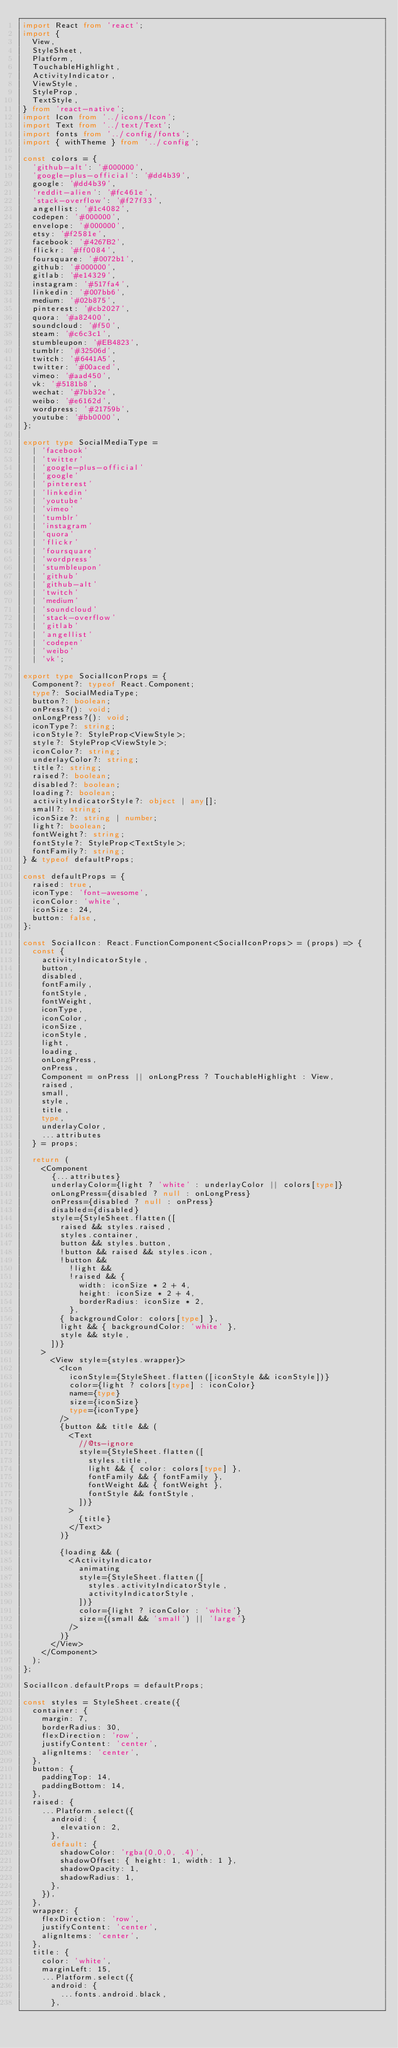Convert code to text. <code><loc_0><loc_0><loc_500><loc_500><_TypeScript_>import React from 'react';
import {
  View,
  StyleSheet,
  Platform,
  TouchableHighlight,
  ActivityIndicator,
  ViewStyle,
  StyleProp,
  TextStyle,
} from 'react-native';
import Icon from '../icons/Icon';
import Text from '../text/Text';
import fonts from '../config/fonts';
import { withTheme } from '../config';

const colors = {
  'github-alt': '#000000',
  'google-plus-official': '#dd4b39',
  google: '#dd4b39',
  'reddit-alien': '#fc461e',
  'stack-overflow': '#f27f33',
  angellist: '#1c4082',
  codepen: '#000000',
  envelope: '#000000',
  etsy: '#f2581e',
  facebook: '#4267B2',
  flickr: '#ff0084',
  foursquare: '#0072b1',
  github: '#000000',
  gitlab: '#e14329',
  instagram: '#517fa4',
  linkedin: '#007bb6',
  medium: '#02b875',
  pinterest: '#cb2027',
  quora: '#a82400',
  soundcloud: '#f50',
  steam: '#c6c3c1',
  stumbleupon: '#EB4823',
  tumblr: '#32506d',
  twitch: '#6441A5',
  twitter: '#00aced',
  vimeo: '#aad450',
  vk: '#5181b8',
  wechat: '#7bb32e',
  weibo: '#e6162d',
  wordpress: '#21759b',
  youtube: '#bb0000',
};

export type SocialMediaType =
  | 'facebook'
  | 'twitter'
  | 'google-plus-official'
  | 'google'
  | 'pinterest'
  | 'linkedin'
  | 'youtube'
  | 'vimeo'
  | 'tumblr'
  | 'instagram'
  | 'quora'
  | 'flickr'
  | 'foursquare'
  | 'wordpress'
  | 'stumbleupon'
  | 'github'
  | 'github-alt'
  | 'twitch'
  | 'medium'
  | 'soundcloud'
  | 'stack-overflow'
  | 'gitlab'
  | 'angellist'
  | 'codepen'
  | 'weibo'
  | 'vk';

export type SocialIconProps = {
  Component?: typeof React.Component;
  type?: SocialMediaType;
  button?: boolean;
  onPress?(): void;
  onLongPress?(): void;
  iconType?: string;
  iconStyle?: StyleProp<ViewStyle>;
  style?: StyleProp<ViewStyle>;
  iconColor?: string;
  underlayColor?: string;
  title?: string;
  raised?: boolean;
  disabled?: boolean;
  loading?: boolean;
  activityIndicatorStyle?: object | any[];
  small?: string;
  iconSize?: string | number;
  light?: boolean;
  fontWeight?: string;
  fontStyle?: StyleProp<TextStyle>;
  fontFamily?: string;
} & typeof defaultProps;

const defaultProps = {
  raised: true,
  iconType: 'font-awesome',
  iconColor: 'white',
  iconSize: 24,
  button: false,
};

const SocialIcon: React.FunctionComponent<SocialIconProps> = (props) => {
  const {
    activityIndicatorStyle,
    button,
    disabled,
    fontFamily,
    fontStyle,
    fontWeight,
    iconType,
    iconColor,
    iconSize,
    iconStyle,
    light,
    loading,
    onLongPress,
    onPress,
    Component = onPress || onLongPress ? TouchableHighlight : View,
    raised,
    small,
    style,
    title,
    type,
    underlayColor,
    ...attributes
  } = props;

  return (
    <Component
      {...attributes}
      underlayColor={light ? 'white' : underlayColor || colors[type]}
      onLongPress={disabled ? null : onLongPress}
      onPress={disabled ? null : onPress}
      disabled={disabled}
      style={StyleSheet.flatten([
        raised && styles.raised,
        styles.container,
        button && styles.button,
        !button && raised && styles.icon,
        !button &&
          !light &&
          !raised && {
            width: iconSize * 2 + 4,
            height: iconSize * 2 + 4,
            borderRadius: iconSize * 2,
          },
        { backgroundColor: colors[type] },
        light && { backgroundColor: 'white' },
        style && style,
      ])}
    >
      <View style={styles.wrapper}>
        <Icon
          iconStyle={StyleSheet.flatten([iconStyle && iconStyle])}
          color={light ? colors[type] : iconColor}
          name={type}
          size={iconSize}
          type={iconType}
        />
        {button && title && (
          <Text
            //@ts-ignore
            style={StyleSheet.flatten([
              styles.title,
              light && { color: colors[type] },
              fontFamily && { fontFamily },
              fontWeight && { fontWeight },
              fontStyle && fontStyle,
            ])}
          >
            {title}
          </Text>
        )}

        {loading && (
          <ActivityIndicator
            animating
            style={StyleSheet.flatten([
              styles.activityIndicatorStyle,
              activityIndicatorStyle,
            ])}
            color={light ? iconColor : 'white'}
            size={(small && 'small') || 'large'}
          />
        )}
      </View>
    </Component>
  );
};

SocialIcon.defaultProps = defaultProps;

const styles = StyleSheet.create({
  container: {
    margin: 7,
    borderRadius: 30,
    flexDirection: 'row',
    justifyContent: 'center',
    alignItems: 'center',
  },
  button: {
    paddingTop: 14,
    paddingBottom: 14,
  },
  raised: {
    ...Platform.select({
      android: {
        elevation: 2,
      },
      default: {
        shadowColor: 'rgba(0,0,0, .4)',
        shadowOffset: { height: 1, width: 1 },
        shadowOpacity: 1,
        shadowRadius: 1,
      },
    }),
  },
  wrapper: {
    flexDirection: 'row',
    justifyContent: 'center',
    alignItems: 'center',
  },
  title: {
    color: 'white',
    marginLeft: 15,
    ...Platform.select({
      android: {
        ...fonts.android.black,
      },</code> 